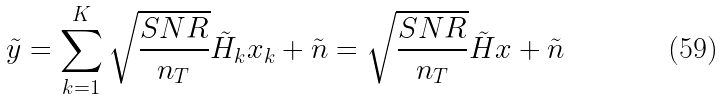Convert formula to latex. <formula><loc_0><loc_0><loc_500><loc_500>\tilde { y } = \sum _ { k = 1 } ^ { K } \sqrt { \frac { S N R } { n _ { T } } } \tilde { H } _ { k } x _ { k } + \tilde { n } = \sqrt { \frac { S N R } { n _ { T } } } \tilde { H } x + \tilde { n }</formula> 